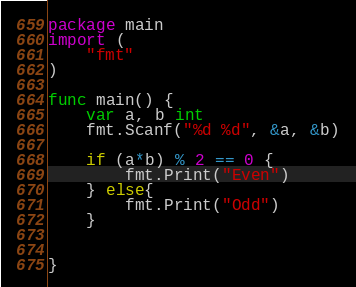Convert code to text. <code><loc_0><loc_0><loc_500><loc_500><_Go_>package main
import (
    "fmt"
)

func main() {
    var a, b int
    fmt.Scanf("%d %d", &a, &b)

    if (a*b) % 2 == 0 {
        fmt.Print("Even")
    } else{
        fmt.Print("Odd")
    }


}</code> 